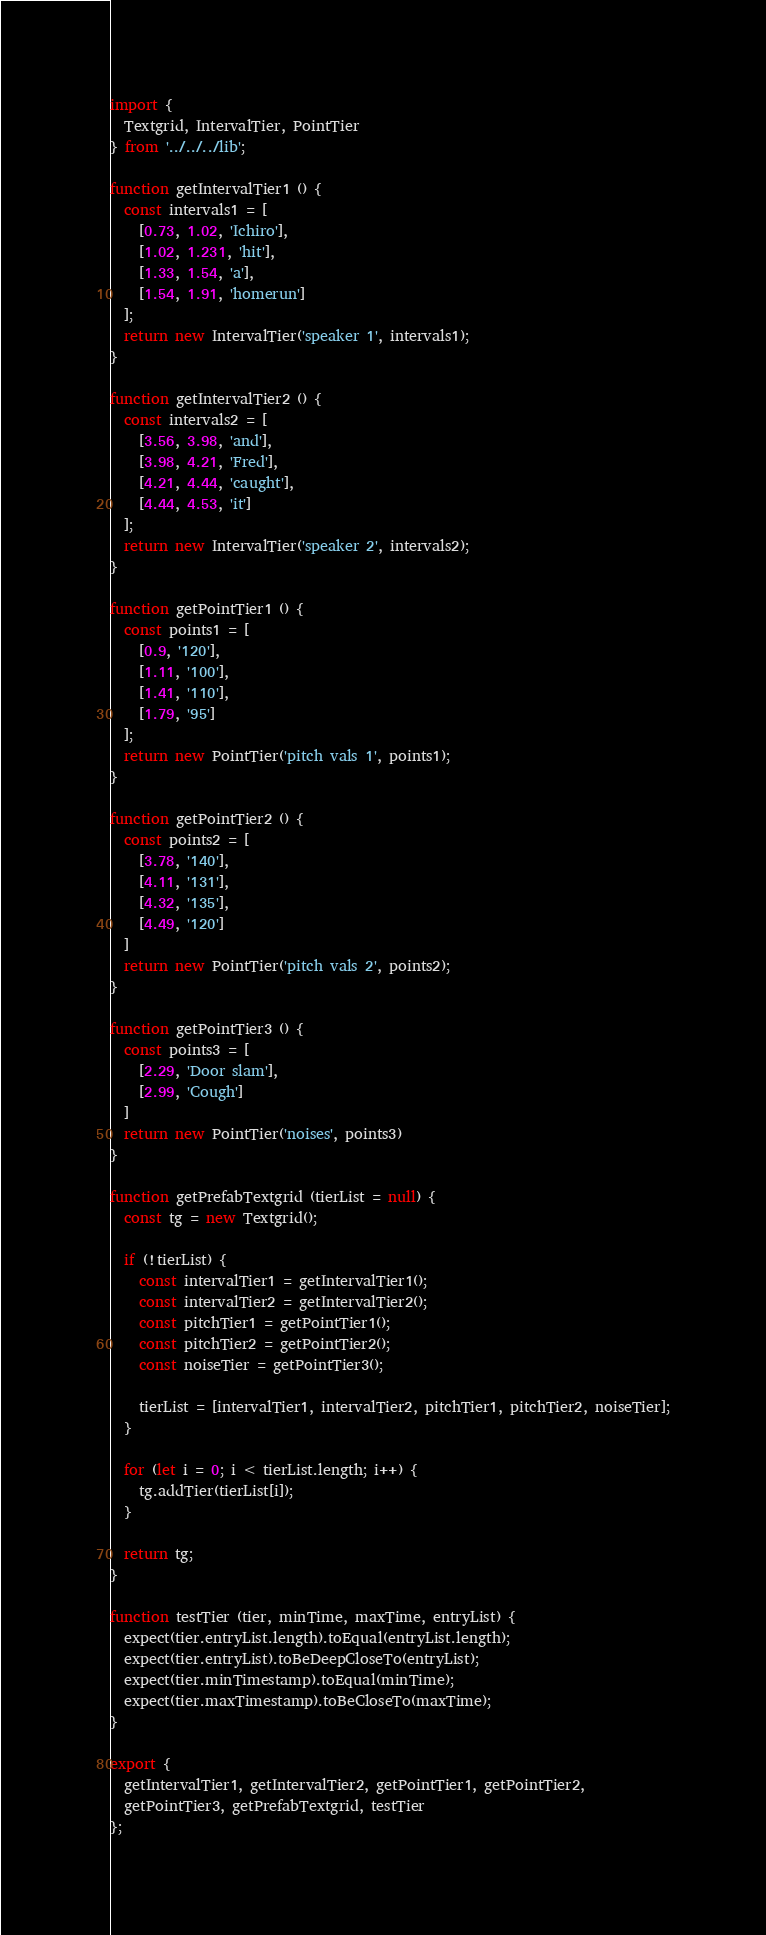<code> <loc_0><loc_0><loc_500><loc_500><_JavaScript_>import {
  Textgrid, IntervalTier, PointTier
} from '../../../lib';

function getIntervalTier1 () {
  const intervals1 = [
    [0.73, 1.02, 'Ichiro'],
    [1.02, 1.231, 'hit'],
    [1.33, 1.54, 'a'],
    [1.54, 1.91, 'homerun']
  ];
  return new IntervalTier('speaker 1', intervals1);
}

function getIntervalTier2 () {
  const intervals2 = [
    [3.56, 3.98, 'and'],
    [3.98, 4.21, 'Fred'],
    [4.21, 4.44, 'caught'],
    [4.44, 4.53, 'it']
  ];
  return new IntervalTier('speaker 2', intervals2);
}

function getPointTier1 () {
  const points1 = [
    [0.9, '120'],
    [1.11, '100'],
    [1.41, '110'],
    [1.79, '95']
  ];
  return new PointTier('pitch vals 1', points1);
}

function getPointTier2 () {
  const points2 = [
    [3.78, '140'],
    [4.11, '131'],
    [4.32, '135'],
    [4.49, '120']
  ]
  return new PointTier('pitch vals 2', points2);
}

function getPointTier3 () {
  const points3 = [
    [2.29, 'Door slam'],
    [2.99, 'Cough']
  ]
  return new PointTier('noises', points3)
}

function getPrefabTextgrid (tierList = null) {
  const tg = new Textgrid();

  if (!tierList) {
    const intervalTier1 = getIntervalTier1();
    const intervalTier2 = getIntervalTier2();
    const pitchTier1 = getPointTier1();
    const pitchTier2 = getPointTier2();
    const noiseTier = getPointTier3();

    tierList = [intervalTier1, intervalTier2, pitchTier1, pitchTier2, noiseTier];
  }

  for (let i = 0; i < tierList.length; i++) {
    tg.addTier(tierList[i]);
  }

  return tg;
}

function testTier (tier, minTime, maxTime, entryList) {
  expect(tier.entryList.length).toEqual(entryList.length);
  expect(tier.entryList).toBeDeepCloseTo(entryList);
  expect(tier.minTimestamp).toEqual(minTime);
  expect(tier.maxTimestamp).toBeCloseTo(maxTime);
}

export {
  getIntervalTier1, getIntervalTier2, getPointTier1, getPointTier2,
  getPointTier3, getPrefabTextgrid, testTier
};
</code> 